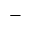<formula> <loc_0><loc_0><loc_500><loc_500>-</formula> 